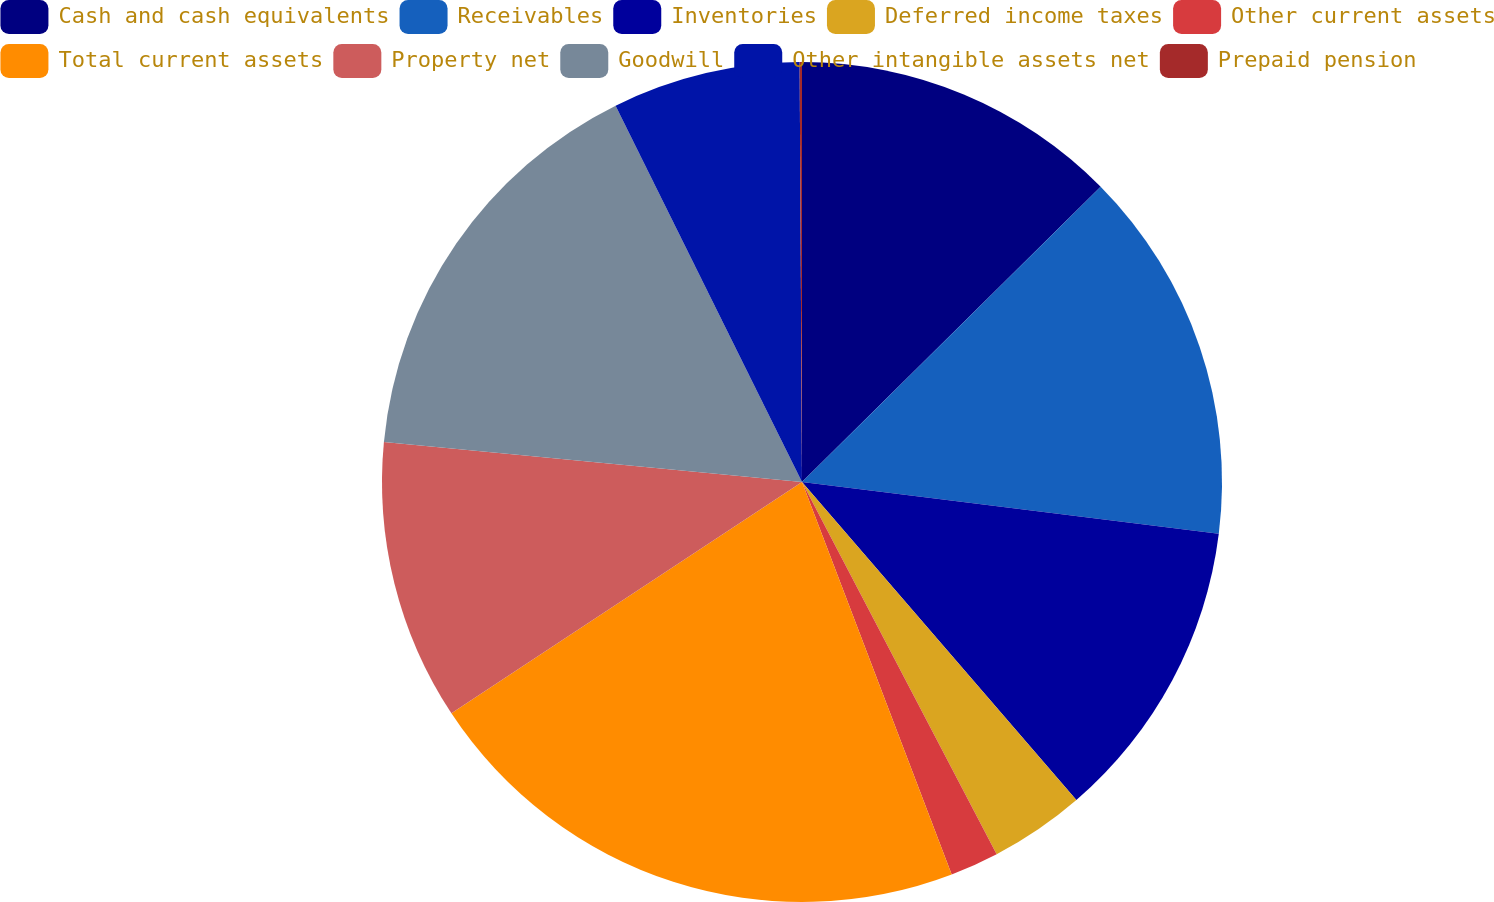Convert chart to OTSL. <chart><loc_0><loc_0><loc_500><loc_500><pie_chart><fcel>Cash and cash equivalents<fcel>Receivables<fcel>Inventories<fcel>Deferred income taxes<fcel>Other current assets<fcel>Total current assets<fcel>Property net<fcel>Goodwill<fcel>Other intangible assets net<fcel>Prepaid pension<nl><fcel>12.59%<fcel>14.38%<fcel>11.7%<fcel>3.66%<fcel>1.87%<fcel>21.52%<fcel>10.8%<fcel>16.16%<fcel>7.23%<fcel>0.09%<nl></chart> 